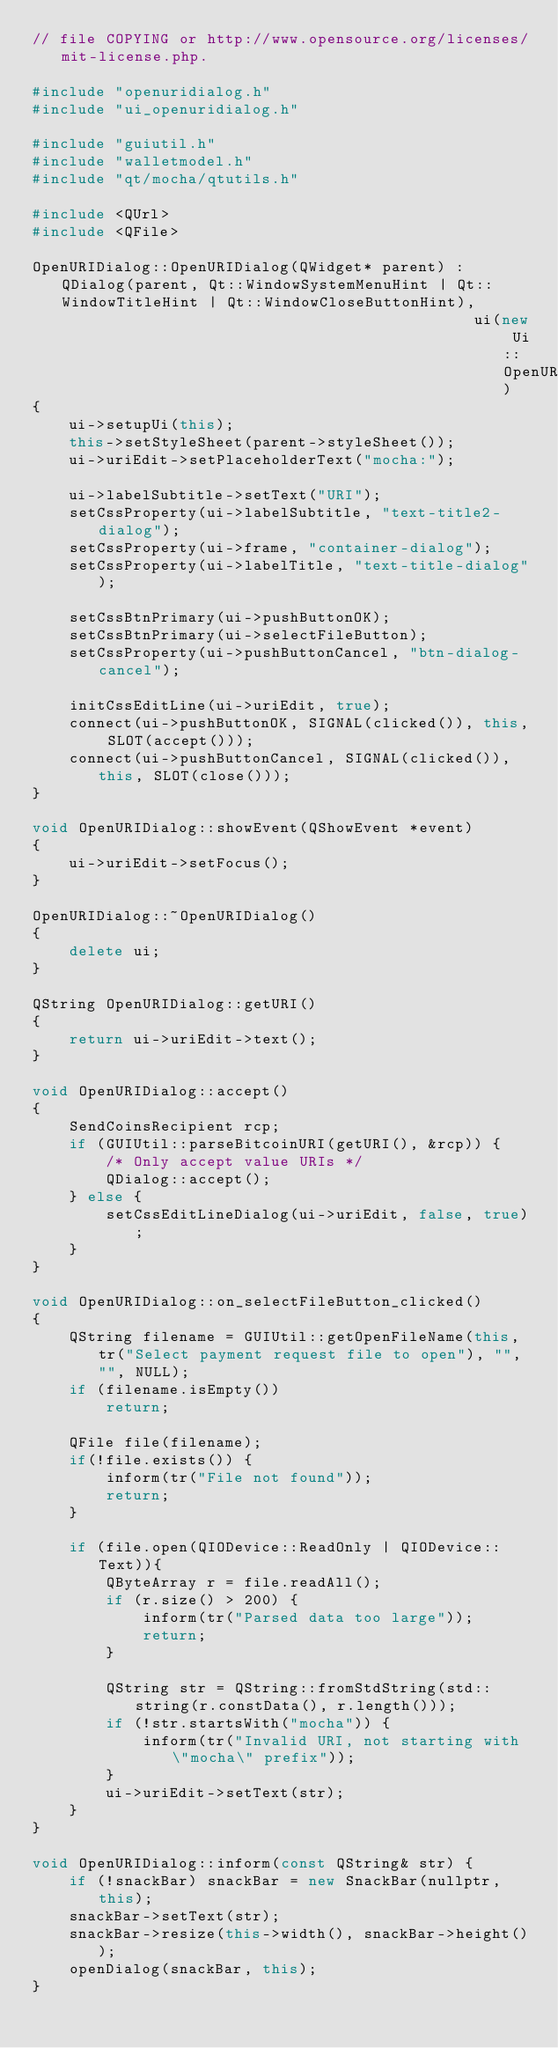Convert code to text. <code><loc_0><loc_0><loc_500><loc_500><_C++_>// file COPYING or http://www.opensource.org/licenses/mit-license.php.

#include "openuridialog.h"
#include "ui_openuridialog.h"

#include "guiutil.h"
#include "walletmodel.h"
#include "qt/mocha/qtutils.h"

#include <QUrl>
#include <QFile>

OpenURIDialog::OpenURIDialog(QWidget* parent) : QDialog(parent, Qt::WindowSystemMenuHint | Qt::WindowTitleHint | Qt::WindowCloseButtonHint),
                                                ui(new Ui::OpenURIDialog)
{
    ui->setupUi(this);
    this->setStyleSheet(parent->styleSheet());
    ui->uriEdit->setPlaceholderText("mocha:");

    ui->labelSubtitle->setText("URI");
    setCssProperty(ui->labelSubtitle, "text-title2-dialog");
    setCssProperty(ui->frame, "container-dialog");
    setCssProperty(ui->labelTitle, "text-title-dialog");

    setCssBtnPrimary(ui->pushButtonOK);
    setCssBtnPrimary(ui->selectFileButton);
    setCssProperty(ui->pushButtonCancel, "btn-dialog-cancel");

    initCssEditLine(ui->uriEdit, true);
    connect(ui->pushButtonOK, SIGNAL(clicked()), this, SLOT(accept()));
    connect(ui->pushButtonCancel, SIGNAL(clicked()), this, SLOT(close()));
}

void OpenURIDialog::showEvent(QShowEvent *event)
{
    ui->uriEdit->setFocus();
}

OpenURIDialog::~OpenURIDialog()
{
    delete ui;
}

QString OpenURIDialog::getURI()
{
    return ui->uriEdit->text();
}

void OpenURIDialog::accept()
{
    SendCoinsRecipient rcp;
    if (GUIUtil::parseBitcoinURI(getURI(), &rcp)) {
        /* Only accept value URIs */
        QDialog::accept();
    } else {
        setCssEditLineDialog(ui->uriEdit, false, true);
    }
}

void OpenURIDialog::on_selectFileButton_clicked()
{
    QString filename = GUIUtil::getOpenFileName(this, tr("Select payment request file to open"), "", "", NULL);
    if (filename.isEmpty())
        return;

    QFile file(filename);
    if(!file.exists()) {
        inform(tr("File not found"));
        return;
    }

    if (file.open(QIODevice::ReadOnly | QIODevice::Text)){
        QByteArray r = file.readAll();
        if (r.size() > 200) {
            inform(tr("Parsed data too large"));
            return;
        }

        QString str = QString::fromStdString(std::string(r.constData(), r.length()));
        if (!str.startsWith("mocha")) {
            inform(tr("Invalid URI, not starting with \"mocha\" prefix"));
        }
        ui->uriEdit->setText(str);
    }
}

void OpenURIDialog::inform(const QString& str) {
    if (!snackBar) snackBar = new SnackBar(nullptr, this);
    snackBar->setText(str);
    snackBar->resize(this->width(), snackBar->height());
    openDialog(snackBar, this);
}</code> 